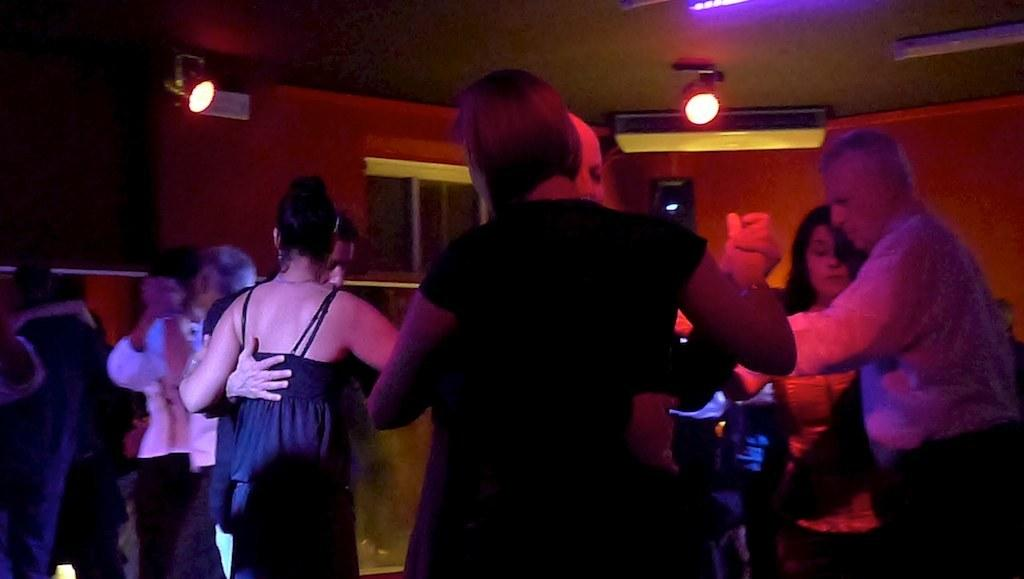What are the persons in the image doing? The persons in the image are dancing on the floor. How can you describe the attire of the persons? The persons are wearing different color dresses. What can be seen attached to the roof in the image? There are lights attached to the roof in the image. What is visible in the background of the image? There is a wall in the background of the image. What type of underwear is visible on the persons in the image? There is no visible underwear on the persons in the image. What can be seen being used by the persons to write on the wall in the image? There is no writing or quill present in the image; the persons are dancing and there is no indication of any writing materials. 